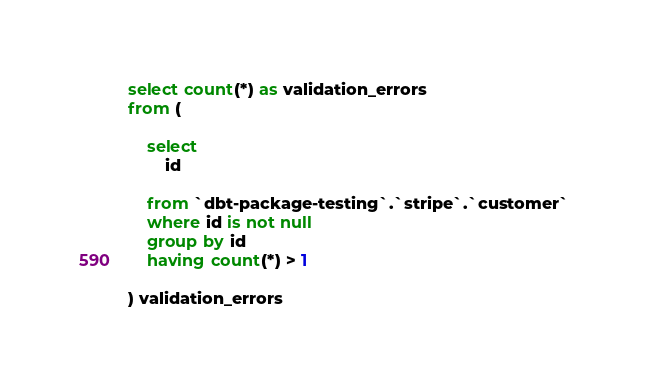Convert code to text. <code><loc_0><loc_0><loc_500><loc_500><_SQL_>



select count(*) as validation_errors
from (

    select
        id

    from `dbt-package-testing`.`stripe`.`customer`
    where id is not null
    group by id
    having count(*) > 1

) validation_errors

</code> 